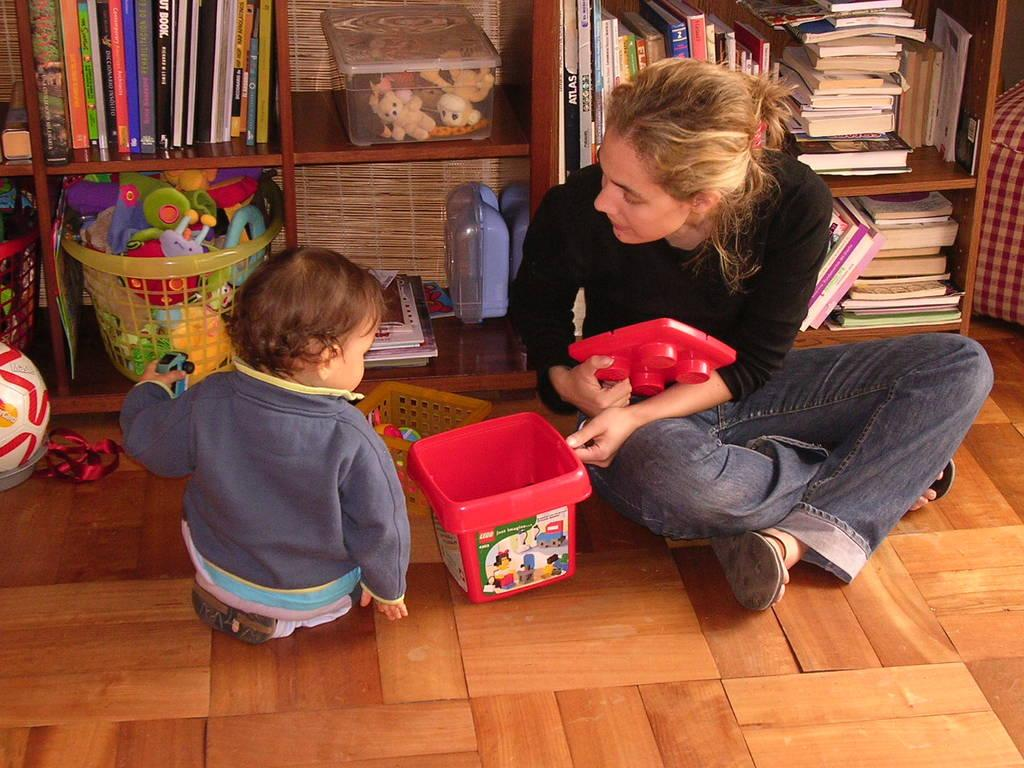Who is present in the image? There is a woman and a child in the image. What are the woman and the child doing in the image? Both the woman and the child are sitting on the floor. What can be seen in the background of the image? There is a wooden shelf in the background of the image. What items are visible in the image related to learning or play? There are books and toys in a basket in the image. What is on the wooden shelf in the image? There are objects on the wooden shelf. What type of cap is the woman wearing in the image? There is no cap visible on the woman in the image. Is there a rifle present in the image? No, there is no rifle present in the image. 